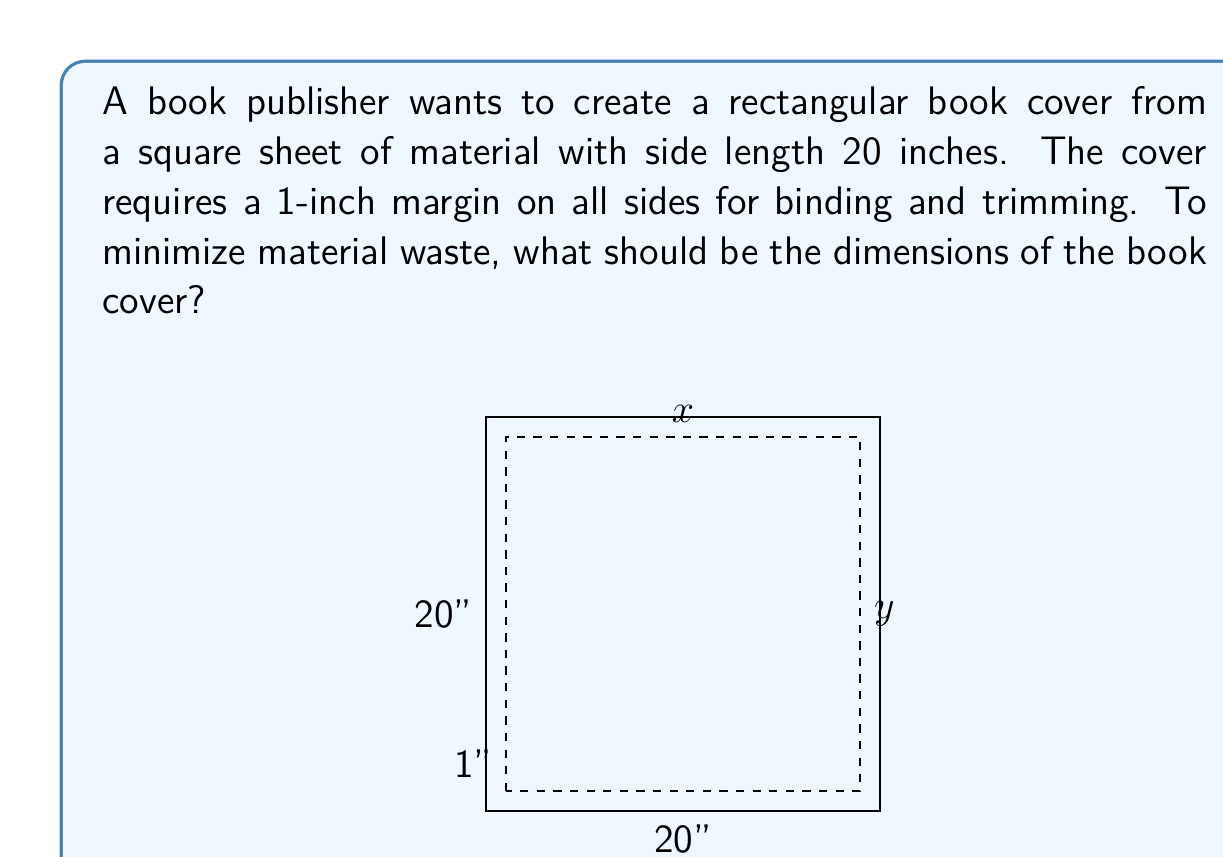Show me your answer to this math problem. Let's approach this step-by-step:

1) Let the width of the book cover be $x$ and the height be $y$.

2) Given the 1-inch margin on all sides, we can express $x$ and $y$ in terms of the sheet size:

   $x + 2 = 20 - y$

3) We want to maximize the area of the book cover. The area $A$ is given by:

   $A = xy$

4) Substituting for $y$ from step 2:

   $A = x(18 - x)$

5) To find the maximum area, we need to find where $\frac{dA}{dx} = 0$:

   $$\frac{dA}{dx} = 18 - 2x$$

6) Setting this equal to zero:

   $18 - 2x = 0$
   $x = 9$

7) The second derivative $\frac{d^2A}{dx^2} = -2$ is negative, confirming this is a maximum.

8) With $x = 9$, we can find $y$:

   $9 + 2 = 20 - y$
   $y = 9$

9) Therefore, the optimal dimensions are 9 inches by 9 inches.

10) To verify the waste is minimized, the total area of the cover is $9 * 9 = 81$ square inches, while the area of the original sheet is $20 * 20 = 400$ square inches. The waste is $400 - 81 = 319$ square inches, which is indeed minimized for a square cover.
Answer: The optimal dimensions of the book cover are 9 inches by 9 inches. 